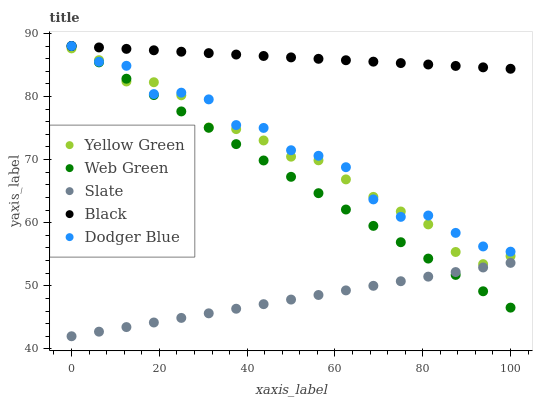Does Slate have the minimum area under the curve?
Answer yes or no. Yes. Does Black have the maximum area under the curve?
Answer yes or no. Yes. Does Black have the minimum area under the curve?
Answer yes or no. No. Does Slate have the maximum area under the curve?
Answer yes or no. No. Is Slate the smoothest?
Answer yes or no. Yes. Is Dodger Blue the roughest?
Answer yes or no. Yes. Is Black the smoothest?
Answer yes or no. No. Is Black the roughest?
Answer yes or no. No. Does Slate have the lowest value?
Answer yes or no. Yes. Does Black have the lowest value?
Answer yes or no. No. Does Web Green have the highest value?
Answer yes or no. Yes. Does Slate have the highest value?
Answer yes or no. No. Is Slate less than Black?
Answer yes or no. Yes. Is Black greater than Yellow Green?
Answer yes or no. Yes. Does Black intersect Dodger Blue?
Answer yes or no. Yes. Is Black less than Dodger Blue?
Answer yes or no. No. Is Black greater than Dodger Blue?
Answer yes or no. No. Does Slate intersect Black?
Answer yes or no. No. 